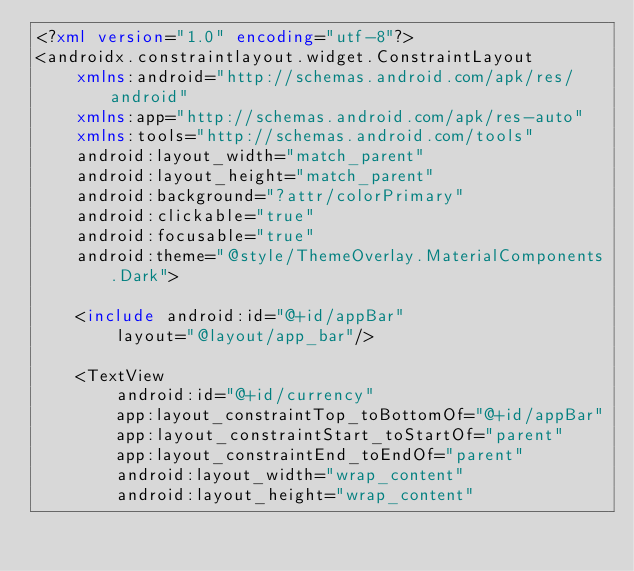Convert code to text. <code><loc_0><loc_0><loc_500><loc_500><_XML_><?xml version="1.0" encoding="utf-8"?>
<androidx.constraintlayout.widget.ConstraintLayout
    xmlns:android="http://schemas.android.com/apk/res/android"
    xmlns:app="http://schemas.android.com/apk/res-auto"
    xmlns:tools="http://schemas.android.com/tools"
    android:layout_width="match_parent"
    android:layout_height="match_parent"
    android:background="?attr/colorPrimary"
    android:clickable="true"
    android:focusable="true"
    android:theme="@style/ThemeOverlay.MaterialComponents.Dark">

    <include android:id="@+id/appBar"
        layout="@layout/app_bar"/>

    <TextView
        android:id="@+id/currency"
        app:layout_constraintTop_toBottomOf="@+id/appBar"
        app:layout_constraintStart_toStartOf="parent"
        app:layout_constraintEnd_toEndOf="parent"
        android:layout_width="wrap_content"
        android:layout_height="wrap_content"</code> 